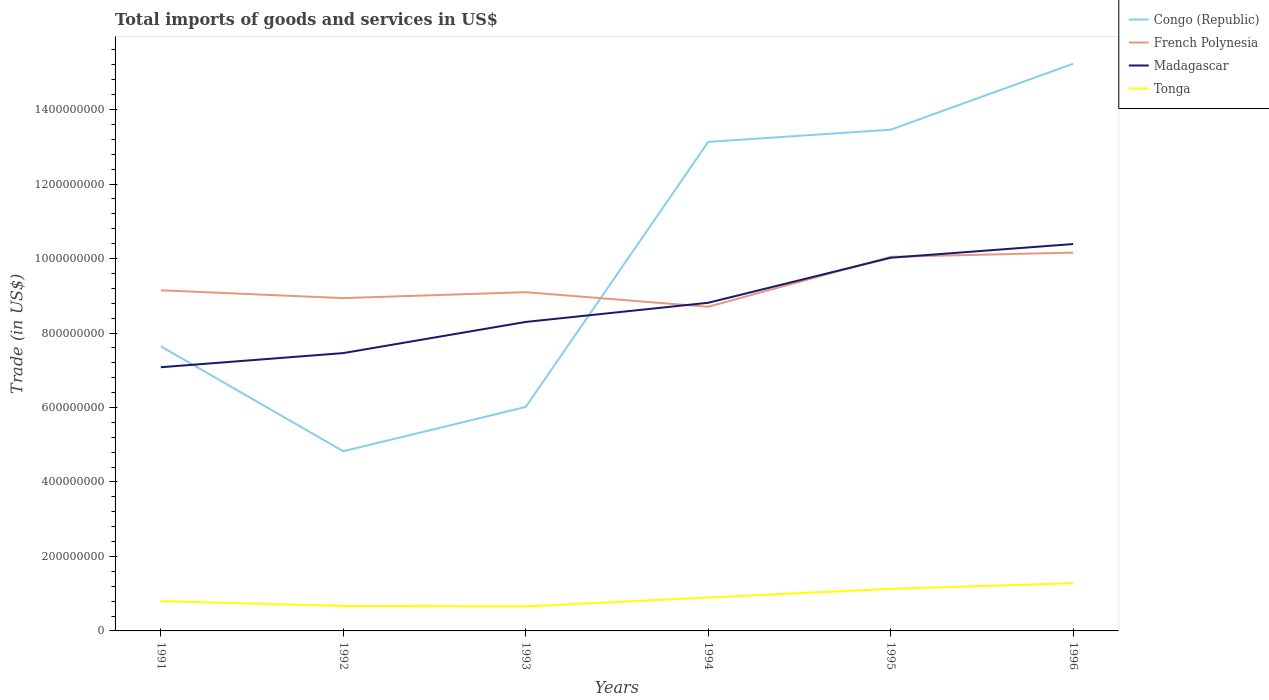Is the number of lines equal to the number of legend labels?
Your answer should be compact. Yes. Across all years, what is the maximum total imports of goods and services in Madagascar?
Make the answer very short. 7.08e+08. What is the total total imports of goods and services in Tonga in the graph?
Give a very brief answer. -4.73e+07. What is the difference between the highest and the second highest total imports of goods and services in French Polynesia?
Provide a succinct answer. 1.45e+08. How many lines are there?
Offer a very short reply. 4. Are the values on the major ticks of Y-axis written in scientific E-notation?
Provide a succinct answer. No. Does the graph contain any zero values?
Make the answer very short. No. How many legend labels are there?
Your response must be concise. 4. What is the title of the graph?
Provide a succinct answer. Total imports of goods and services in US$. Does "Burkina Faso" appear as one of the legend labels in the graph?
Ensure brevity in your answer.  No. What is the label or title of the Y-axis?
Give a very brief answer. Trade (in US$). What is the Trade (in US$) of Congo (Republic) in 1991?
Offer a terse response. 7.64e+08. What is the Trade (in US$) in French Polynesia in 1991?
Your response must be concise. 9.15e+08. What is the Trade (in US$) in Madagascar in 1991?
Give a very brief answer. 7.08e+08. What is the Trade (in US$) of Tonga in 1991?
Make the answer very short. 8.01e+07. What is the Trade (in US$) in Congo (Republic) in 1992?
Offer a terse response. 4.82e+08. What is the Trade (in US$) in French Polynesia in 1992?
Keep it short and to the point. 8.94e+08. What is the Trade (in US$) of Madagascar in 1992?
Your answer should be compact. 7.46e+08. What is the Trade (in US$) of Tonga in 1992?
Give a very brief answer. 6.71e+07. What is the Trade (in US$) in Congo (Republic) in 1993?
Keep it short and to the point. 6.01e+08. What is the Trade (in US$) of French Polynesia in 1993?
Offer a terse response. 9.10e+08. What is the Trade (in US$) of Madagascar in 1993?
Your response must be concise. 8.30e+08. What is the Trade (in US$) in Tonga in 1993?
Provide a succinct answer. 6.59e+07. What is the Trade (in US$) of Congo (Republic) in 1994?
Your answer should be very brief. 1.31e+09. What is the Trade (in US$) in French Polynesia in 1994?
Your answer should be compact. 8.70e+08. What is the Trade (in US$) in Madagascar in 1994?
Make the answer very short. 8.81e+08. What is the Trade (in US$) in Tonga in 1994?
Keep it short and to the point. 8.97e+07. What is the Trade (in US$) of Congo (Republic) in 1995?
Ensure brevity in your answer.  1.35e+09. What is the Trade (in US$) in French Polynesia in 1995?
Your answer should be compact. 1.00e+09. What is the Trade (in US$) in Madagascar in 1995?
Make the answer very short. 1.00e+09. What is the Trade (in US$) of Tonga in 1995?
Ensure brevity in your answer.  1.13e+08. What is the Trade (in US$) of Congo (Republic) in 1996?
Provide a short and direct response. 1.52e+09. What is the Trade (in US$) of French Polynesia in 1996?
Offer a very short reply. 1.02e+09. What is the Trade (in US$) of Madagascar in 1996?
Keep it short and to the point. 1.04e+09. What is the Trade (in US$) in Tonga in 1996?
Give a very brief answer. 1.28e+08. Across all years, what is the maximum Trade (in US$) of Congo (Republic)?
Ensure brevity in your answer.  1.52e+09. Across all years, what is the maximum Trade (in US$) in French Polynesia?
Ensure brevity in your answer.  1.02e+09. Across all years, what is the maximum Trade (in US$) in Madagascar?
Provide a short and direct response. 1.04e+09. Across all years, what is the maximum Trade (in US$) in Tonga?
Make the answer very short. 1.28e+08. Across all years, what is the minimum Trade (in US$) of Congo (Republic)?
Provide a succinct answer. 4.82e+08. Across all years, what is the minimum Trade (in US$) of French Polynesia?
Keep it short and to the point. 8.70e+08. Across all years, what is the minimum Trade (in US$) in Madagascar?
Provide a succinct answer. 7.08e+08. Across all years, what is the minimum Trade (in US$) in Tonga?
Make the answer very short. 6.59e+07. What is the total Trade (in US$) in Congo (Republic) in the graph?
Provide a short and direct response. 6.03e+09. What is the total Trade (in US$) of French Polynesia in the graph?
Keep it short and to the point. 5.61e+09. What is the total Trade (in US$) of Madagascar in the graph?
Offer a terse response. 5.21e+09. What is the total Trade (in US$) of Tonga in the graph?
Your answer should be compact. 5.44e+08. What is the difference between the Trade (in US$) of Congo (Republic) in 1991 and that in 1992?
Provide a succinct answer. 2.82e+08. What is the difference between the Trade (in US$) of French Polynesia in 1991 and that in 1992?
Your answer should be compact. 2.10e+07. What is the difference between the Trade (in US$) of Madagascar in 1991 and that in 1992?
Your response must be concise. -3.80e+07. What is the difference between the Trade (in US$) in Tonga in 1991 and that in 1992?
Keep it short and to the point. 1.29e+07. What is the difference between the Trade (in US$) of Congo (Republic) in 1991 and that in 1993?
Ensure brevity in your answer.  1.63e+08. What is the difference between the Trade (in US$) in French Polynesia in 1991 and that in 1993?
Keep it short and to the point. 5.07e+06. What is the difference between the Trade (in US$) of Madagascar in 1991 and that in 1993?
Your answer should be compact. -1.22e+08. What is the difference between the Trade (in US$) in Tonga in 1991 and that in 1993?
Offer a very short reply. 1.42e+07. What is the difference between the Trade (in US$) of Congo (Republic) in 1991 and that in 1994?
Provide a short and direct response. -5.49e+08. What is the difference between the Trade (in US$) of French Polynesia in 1991 and that in 1994?
Make the answer very short. 4.42e+07. What is the difference between the Trade (in US$) of Madagascar in 1991 and that in 1994?
Provide a short and direct response. -1.73e+08. What is the difference between the Trade (in US$) of Tonga in 1991 and that in 1994?
Keep it short and to the point. -9.66e+06. What is the difference between the Trade (in US$) of Congo (Republic) in 1991 and that in 1995?
Keep it short and to the point. -5.82e+08. What is the difference between the Trade (in US$) of French Polynesia in 1991 and that in 1995?
Offer a terse response. -9.00e+07. What is the difference between the Trade (in US$) of Madagascar in 1991 and that in 1995?
Offer a very short reply. -2.94e+08. What is the difference between the Trade (in US$) in Tonga in 1991 and that in 1995?
Your response must be concise. -3.31e+07. What is the difference between the Trade (in US$) of Congo (Republic) in 1991 and that in 1996?
Your answer should be very brief. -7.59e+08. What is the difference between the Trade (in US$) of French Polynesia in 1991 and that in 1996?
Provide a succinct answer. -1.01e+08. What is the difference between the Trade (in US$) of Madagascar in 1991 and that in 1996?
Give a very brief answer. -3.31e+08. What is the difference between the Trade (in US$) in Tonga in 1991 and that in 1996?
Your answer should be compact. -4.81e+07. What is the difference between the Trade (in US$) of Congo (Republic) in 1992 and that in 1993?
Give a very brief answer. -1.19e+08. What is the difference between the Trade (in US$) in French Polynesia in 1992 and that in 1993?
Give a very brief answer. -1.59e+07. What is the difference between the Trade (in US$) of Madagascar in 1992 and that in 1993?
Keep it short and to the point. -8.37e+07. What is the difference between the Trade (in US$) in Tonga in 1992 and that in 1993?
Provide a succinct answer. 1.30e+06. What is the difference between the Trade (in US$) in Congo (Republic) in 1992 and that in 1994?
Make the answer very short. -8.31e+08. What is the difference between the Trade (in US$) of French Polynesia in 1992 and that in 1994?
Your answer should be very brief. 2.32e+07. What is the difference between the Trade (in US$) in Madagascar in 1992 and that in 1994?
Offer a very short reply. -1.35e+08. What is the difference between the Trade (in US$) of Tonga in 1992 and that in 1994?
Ensure brevity in your answer.  -2.26e+07. What is the difference between the Trade (in US$) in Congo (Republic) in 1992 and that in 1995?
Your response must be concise. -8.63e+08. What is the difference between the Trade (in US$) in French Polynesia in 1992 and that in 1995?
Make the answer very short. -1.11e+08. What is the difference between the Trade (in US$) of Madagascar in 1992 and that in 1995?
Ensure brevity in your answer.  -2.56e+08. What is the difference between the Trade (in US$) in Tonga in 1992 and that in 1995?
Your response must be concise. -4.60e+07. What is the difference between the Trade (in US$) in Congo (Republic) in 1992 and that in 1996?
Provide a short and direct response. -1.04e+09. What is the difference between the Trade (in US$) in French Polynesia in 1992 and that in 1996?
Provide a short and direct response. -1.22e+08. What is the difference between the Trade (in US$) of Madagascar in 1992 and that in 1996?
Give a very brief answer. -2.93e+08. What is the difference between the Trade (in US$) in Tonga in 1992 and that in 1996?
Your response must be concise. -6.10e+07. What is the difference between the Trade (in US$) of Congo (Republic) in 1993 and that in 1994?
Keep it short and to the point. -7.12e+08. What is the difference between the Trade (in US$) of French Polynesia in 1993 and that in 1994?
Offer a very short reply. 3.92e+07. What is the difference between the Trade (in US$) in Madagascar in 1993 and that in 1994?
Provide a succinct answer. -5.14e+07. What is the difference between the Trade (in US$) of Tonga in 1993 and that in 1994?
Your answer should be very brief. -2.39e+07. What is the difference between the Trade (in US$) of Congo (Republic) in 1993 and that in 1995?
Give a very brief answer. -7.45e+08. What is the difference between the Trade (in US$) in French Polynesia in 1993 and that in 1995?
Ensure brevity in your answer.  -9.50e+07. What is the difference between the Trade (in US$) in Madagascar in 1993 and that in 1995?
Your answer should be compact. -1.72e+08. What is the difference between the Trade (in US$) of Tonga in 1993 and that in 1995?
Your answer should be very brief. -4.73e+07. What is the difference between the Trade (in US$) of Congo (Republic) in 1993 and that in 1996?
Give a very brief answer. -9.22e+08. What is the difference between the Trade (in US$) in French Polynesia in 1993 and that in 1996?
Offer a terse response. -1.06e+08. What is the difference between the Trade (in US$) of Madagascar in 1993 and that in 1996?
Your response must be concise. -2.09e+08. What is the difference between the Trade (in US$) of Tonga in 1993 and that in 1996?
Your response must be concise. -6.23e+07. What is the difference between the Trade (in US$) in Congo (Republic) in 1994 and that in 1995?
Offer a terse response. -3.27e+07. What is the difference between the Trade (in US$) in French Polynesia in 1994 and that in 1995?
Keep it short and to the point. -1.34e+08. What is the difference between the Trade (in US$) in Madagascar in 1994 and that in 1995?
Ensure brevity in your answer.  -1.21e+08. What is the difference between the Trade (in US$) of Tonga in 1994 and that in 1995?
Offer a very short reply. -2.34e+07. What is the difference between the Trade (in US$) in Congo (Republic) in 1994 and that in 1996?
Your answer should be compact. -2.10e+08. What is the difference between the Trade (in US$) in French Polynesia in 1994 and that in 1996?
Provide a short and direct response. -1.45e+08. What is the difference between the Trade (in US$) of Madagascar in 1994 and that in 1996?
Provide a succinct answer. -1.58e+08. What is the difference between the Trade (in US$) in Tonga in 1994 and that in 1996?
Your answer should be compact. -3.85e+07. What is the difference between the Trade (in US$) in Congo (Republic) in 1995 and that in 1996?
Your response must be concise. -1.77e+08. What is the difference between the Trade (in US$) in French Polynesia in 1995 and that in 1996?
Your answer should be very brief. -1.12e+07. What is the difference between the Trade (in US$) in Madagascar in 1995 and that in 1996?
Provide a succinct answer. -3.68e+07. What is the difference between the Trade (in US$) in Tonga in 1995 and that in 1996?
Your response must be concise. -1.51e+07. What is the difference between the Trade (in US$) in Congo (Republic) in 1991 and the Trade (in US$) in French Polynesia in 1992?
Your answer should be compact. -1.29e+08. What is the difference between the Trade (in US$) of Congo (Republic) in 1991 and the Trade (in US$) of Madagascar in 1992?
Offer a very short reply. 1.83e+07. What is the difference between the Trade (in US$) of Congo (Republic) in 1991 and the Trade (in US$) of Tonga in 1992?
Ensure brevity in your answer.  6.97e+08. What is the difference between the Trade (in US$) of French Polynesia in 1991 and the Trade (in US$) of Madagascar in 1992?
Give a very brief answer. 1.69e+08. What is the difference between the Trade (in US$) in French Polynesia in 1991 and the Trade (in US$) in Tonga in 1992?
Your answer should be compact. 8.48e+08. What is the difference between the Trade (in US$) in Madagascar in 1991 and the Trade (in US$) in Tonga in 1992?
Keep it short and to the point. 6.41e+08. What is the difference between the Trade (in US$) of Congo (Republic) in 1991 and the Trade (in US$) of French Polynesia in 1993?
Provide a succinct answer. -1.45e+08. What is the difference between the Trade (in US$) in Congo (Republic) in 1991 and the Trade (in US$) in Madagascar in 1993?
Ensure brevity in your answer.  -6.54e+07. What is the difference between the Trade (in US$) of Congo (Republic) in 1991 and the Trade (in US$) of Tonga in 1993?
Provide a short and direct response. 6.98e+08. What is the difference between the Trade (in US$) of French Polynesia in 1991 and the Trade (in US$) of Madagascar in 1993?
Ensure brevity in your answer.  8.49e+07. What is the difference between the Trade (in US$) of French Polynesia in 1991 and the Trade (in US$) of Tonga in 1993?
Your response must be concise. 8.49e+08. What is the difference between the Trade (in US$) of Madagascar in 1991 and the Trade (in US$) of Tonga in 1993?
Offer a very short reply. 6.42e+08. What is the difference between the Trade (in US$) of Congo (Republic) in 1991 and the Trade (in US$) of French Polynesia in 1994?
Offer a very short reply. -1.06e+08. What is the difference between the Trade (in US$) in Congo (Republic) in 1991 and the Trade (in US$) in Madagascar in 1994?
Give a very brief answer. -1.17e+08. What is the difference between the Trade (in US$) in Congo (Republic) in 1991 and the Trade (in US$) in Tonga in 1994?
Your response must be concise. 6.75e+08. What is the difference between the Trade (in US$) of French Polynesia in 1991 and the Trade (in US$) of Madagascar in 1994?
Provide a succinct answer. 3.35e+07. What is the difference between the Trade (in US$) of French Polynesia in 1991 and the Trade (in US$) of Tonga in 1994?
Give a very brief answer. 8.25e+08. What is the difference between the Trade (in US$) of Madagascar in 1991 and the Trade (in US$) of Tonga in 1994?
Your answer should be compact. 6.18e+08. What is the difference between the Trade (in US$) in Congo (Republic) in 1991 and the Trade (in US$) in French Polynesia in 1995?
Offer a very short reply. -2.40e+08. What is the difference between the Trade (in US$) of Congo (Republic) in 1991 and the Trade (in US$) of Madagascar in 1995?
Keep it short and to the point. -2.38e+08. What is the difference between the Trade (in US$) of Congo (Republic) in 1991 and the Trade (in US$) of Tonga in 1995?
Provide a short and direct response. 6.51e+08. What is the difference between the Trade (in US$) of French Polynesia in 1991 and the Trade (in US$) of Madagascar in 1995?
Provide a succinct answer. -8.74e+07. What is the difference between the Trade (in US$) in French Polynesia in 1991 and the Trade (in US$) in Tonga in 1995?
Make the answer very short. 8.02e+08. What is the difference between the Trade (in US$) of Madagascar in 1991 and the Trade (in US$) of Tonga in 1995?
Ensure brevity in your answer.  5.95e+08. What is the difference between the Trade (in US$) of Congo (Republic) in 1991 and the Trade (in US$) of French Polynesia in 1996?
Offer a terse response. -2.52e+08. What is the difference between the Trade (in US$) in Congo (Republic) in 1991 and the Trade (in US$) in Madagascar in 1996?
Provide a succinct answer. -2.75e+08. What is the difference between the Trade (in US$) of Congo (Republic) in 1991 and the Trade (in US$) of Tonga in 1996?
Your answer should be very brief. 6.36e+08. What is the difference between the Trade (in US$) in French Polynesia in 1991 and the Trade (in US$) in Madagascar in 1996?
Offer a terse response. -1.24e+08. What is the difference between the Trade (in US$) in French Polynesia in 1991 and the Trade (in US$) in Tonga in 1996?
Give a very brief answer. 7.86e+08. What is the difference between the Trade (in US$) of Madagascar in 1991 and the Trade (in US$) of Tonga in 1996?
Offer a very short reply. 5.80e+08. What is the difference between the Trade (in US$) of Congo (Republic) in 1992 and the Trade (in US$) of French Polynesia in 1993?
Provide a succinct answer. -4.27e+08. What is the difference between the Trade (in US$) in Congo (Republic) in 1992 and the Trade (in US$) in Madagascar in 1993?
Make the answer very short. -3.47e+08. What is the difference between the Trade (in US$) in Congo (Republic) in 1992 and the Trade (in US$) in Tonga in 1993?
Offer a terse response. 4.17e+08. What is the difference between the Trade (in US$) of French Polynesia in 1992 and the Trade (in US$) of Madagascar in 1993?
Give a very brief answer. 6.39e+07. What is the difference between the Trade (in US$) in French Polynesia in 1992 and the Trade (in US$) in Tonga in 1993?
Make the answer very short. 8.28e+08. What is the difference between the Trade (in US$) in Madagascar in 1992 and the Trade (in US$) in Tonga in 1993?
Ensure brevity in your answer.  6.80e+08. What is the difference between the Trade (in US$) in Congo (Republic) in 1992 and the Trade (in US$) in French Polynesia in 1994?
Provide a short and direct response. -3.88e+08. What is the difference between the Trade (in US$) of Congo (Republic) in 1992 and the Trade (in US$) of Madagascar in 1994?
Keep it short and to the point. -3.99e+08. What is the difference between the Trade (in US$) in Congo (Republic) in 1992 and the Trade (in US$) in Tonga in 1994?
Ensure brevity in your answer.  3.93e+08. What is the difference between the Trade (in US$) in French Polynesia in 1992 and the Trade (in US$) in Madagascar in 1994?
Keep it short and to the point. 1.25e+07. What is the difference between the Trade (in US$) of French Polynesia in 1992 and the Trade (in US$) of Tonga in 1994?
Your answer should be very brief. 8.04e+08. What is the difference between the Trade (in US$) in Madagascar in 1992 and the Trade (in US$) in Tonga in 1994?
Your answer should be compact. 6.56e+08. What is the difference between the Trade (in US$) in Congo (Republic) in 1992 and the Trade (in US$) in French Polynesia in 1995?
Your answer should be compact. -5.22e+08. What is the difference between the Trade (in US$) of Congo (Republic) in 1992 and the Trade (in US$) of Madagascar in 1995?
Give a very brief answer. -5.20e+08. What is the difference between the Trade (in US$) in Congo (Republic) in 1992 and the Trade (in US$) in Tonga in 1995?
Your answer should be compact. 3.69e+08. What is the difference between the Trade (in US$) in French Polynesia in 1992 and the Trade (in US$) in Madagascar in 1995?
Keep it short and to the point. -1.08e+08. What is the difference between the Trade (in US$) of French Polynesia in 1992 and the Trade (in US$) of Tonga in 1995?
Make the answer very short. 7.81e+08. What is the difference between the Trade (in US$) of Madagascar in 1992 and the Trade (in US$) of Tonga in 1995?
Give a very brief answer. 6.33e+08. What is the difference between the Trade (in US$) of Congo (Republic) in 1992 and the Trade (in US$) of French Polynesia in 1996?
Provide a succinct answer. -5.33e+08. What is the difference between the Trade (in US$) in Congo (Republic) in 1992 and the Trade (in US$) in Madagascar in 1996?
Offer a terse response. -5.56e+08. What is the difference between the Trade (in US$) of Congo (Republic) in 1992 and the Trade (in US$) of Tonga in 1996?
Your answer should be compact. 3.54e+08. What is the difference between the Trade (in US$) of French Polynesia in 1992 and the Trade (in US$) of Madagascar in 1996?
Your answer should be very brief. -1.45e+08. What is the difference between the Trade (in US$) of French Polynesia in 1992 and the Trade (in US$) of Tonga in 1996?
Your answer should be compact. 7.65e+08. What is the difference between the Trade (in US$) of Madagascar in 1992 and the Trade (in US$) of Tonga in 1996?
Your response must be concise. 6.18e+08. What is the difference between the Trade (in US$) in Congo (Republic) in 1993 and the Trade (in US$) in French Polynesia in 1994?
Ensure brevity in your answer.  -2.69e+08. What is the difference between the Trade (in US$) of Congo (Republic) in 1993 and the Trade (in US$) of Madagascar in 1994?
Make the answer very short. -2.80e+08. What is the difference between the Trade (in US$) of Congo (Republic) in 1993 and the Trade (in US$) of Tonga in 1994?
Your answer should be very brief. 5.12e+08. What is the difference between the Trade (in US$) in French Polynesia in 1993 and the Trade (in US$) in Madagascar in 1994?
Keep it short and to the point. 2.84e+07. What is the difference between the Trade (in US$) of French Polynesia in 1993 and the Trade (in US$) of Tonga in 1994?
Your answer should be very brief. 8.20e+08. What is the difference between the Trade (in US$) of Madagascar in 1993 and the Trade (in US$) of Tonga in 1994?
Your answer should be very brief. 7.40e+08. What is the difference between the Trade (in US$) of Congo (Republic) in 1993 and the Trade (in US$) of French Polynesia in 1995?
Keep it short and to the point. -4.03e+08. What is the difference between the Trade (in US$) of Congo (Republic) in 1993 and the Trade (in US$) of Madagascar in 1995?
Make the answer very short. -4.01e+08. What is the difference between the Trade (in US$) of Congo (Republic) in 1993 and the Trade (in US$) of Tonga in 1995?
Make the answer very short. 4.88e+08. What is the difference between the Trade (in US$) in French Polynesia in 1993 and the Trade (in US$) in Madagascar in 1995?
Provide a short and direct response. -9.25e+07. What is the difference between the Trade (in US$) of French Polynesia in 1993 and the Trade (in US$) of Tonga in 1995?
Offer a terse response. 7.96e+08. What is the difference between the Trade (in US$) in Madagascar in 1993 and the Trade (in US$) in Tonga in 1995?
Your answer should be compact. 7.17e+08. What is the difference between the Trade (in US$) in Congo (Republic) in 1993 and the Trade (in US$) in French Polynesia in 1996?
Your response must be concise. -4.14e+08. What is the difference between the Trade (in US$) of Congo (Republic) in 1993 and the Trade (in US$) of Madagascar in 1996?
Ensure brevity in your answer.  -4.37e+08. What is the difference between the Trade (in US$) of Congo (Republic) in 1993 and the Trade (in US$) of Tonga in 1996?
Offer a terse response. 4.73e+08. What is the difference between the Trade (in US$) of French Polynesia in 1993 and the Trade (in US$) of Madagascar in 1996?
Ensure brevity in your answer.  -1.29e+08. What is the difference between the Trade (in US$) of French Polynesia in 1993 and the Trade (in US$) of Tonga in 1996?
Ensure brevity in your answer.  7.81e+08. What is the difference between the Trade (in US$) in Madagascar in 1993 and the Trade (in US$) in Tonga in 1996?
Make the answer very short. 7.02e+08. What is the difference between the Trade (in US$) of Congo (Republic) in 1994 and the Trade (in US$) of French Polynesia in 1995?
Your answer should be very brief. 3.09e+08. What is the difference between the Trade (in US$) of Congo (Republic) in 1994 and the Trade (in US$) of Madagascar in 1995?
Provide a short and direct response. 3.11e+08. What is the difference between the Trade (in US$) in Congo (Republic) in 1994 and the Trade (in US$) in Tonga in 1995?
Give a very brief answer. 1.20e+09. What is the difference between the Trade (in US$) in French Polynesia in 1994 and the Trade (in US$) in Madagascar in 1995?
Offer a very short reply. -1.32e+08. What is the difference between the Trade (in US$) in French Polynesia in 1994 and the Trade (in US$) in Tonga in 1995?
Your answer should be very brief. 7.57e+08. What is the difference between the Trade (in US$) in Madagascar in 1994 and the Trade (in US$) in Tonga in 1995?
Give a very brief answer. 7.68e+08. What is the difference between the Trade (in US$) of Congo (Republic) in 1994 and the Trade (in US$) of French Polynesia in 1996?
Your answer should be compact. 2.97e+08. What is the difference between the Trade (in US$) in Congo (Republic) in 1994 and the Trade (in US$) in Madagascar in 1996?
Give a very brief answer. 2.74e+08. What is the difference between the Trade (in US$) of Congo (Republic) in 1994 and the Trade (in US$) of Tonga in 1996?
Offer a terse response. 1.19e+09. What is the difference between the Trade (in US$) of French Polynesia in 1994 and the Trade (in US$) of Madagascar in 1996?
Your response must be concise. -1.68e+08. What is the difference between the Trade (in US$) in French Polynesia in 1994 and the Trade (in US$) in Tonga in 1996?
Give a very brief answer. 7.42e+08. What is the difference between the Trade (in US$) of Madagascar in 1994 and the Trade (in US$) of Tonga in 1996?
Offer a terse response. 7.53e+08. What is the difference between the Trade (in US$) in Congo (Republic) in 1995 and the Trade (in US$) in French Polynesia in 1996?
Provide a succinct answer. 3.30e+08. What is the difference between the Trade (in US$) of Congo (Republic) in 1995 and the Trade (in US$) of Madagascar in 1996?
Your answer should be very brief. 3.07e+08. What is the difference between the Trade (in US$) in Congo (Republic) in 1995 and the Trade (in US$) in Tonga in 1996?
Ensure brevity in your answer.  1.22e+09. What is the difference between the Trade (in US$) in French Polynesia in 1995 and the Trade (in US$) in Madagascar in 1996?
Offer a terse response. -3.43e+07. What is the difference between the Trade (in US$) in French Polynesia in 1995 and the Trade (in US$) in Tonga in 1996?
Give a very brief answer. 8.76e+08. What is the difference between the Trade (in US$) of Madagascar in 1995 and the Trade (in US$) of Tonga in 1996?
Provide a succinct answer. 8.74e+08. What is the average Trade (in US$) of Congo (Republic) per year?
Ensure brevity in your answer.  1.01e+09. What is the average Trade (in US$) in French Polynesia per year?
Your answer should be very brief. 9.35e+08. What is the average Trade (in US$) of Madagascar per year?
Your answer should be very brief. 8.68e+08. What is the average Trade (in US$) of Tonga per year?
Offer a terse response. 9.07e+07. In the year 1991, what is the difference between the Trade (in US$) in Congo (Republic) and Trade (in US$) in French Polynesia?
Make the answer very short. -1.50e+08. In the year 1991, what is the difference between the Trade (in US$) of Congo (Republic) and Trade (in US$) of Madagascar?
Give a very brief answer. 5.62e+07. In the year 1991, what is the difference between the Trade (in US$) of Congo (Republic) and Trade (in US$) of Tonga?
Provide a succinct answer. 6.84e+08. In the year 1991, what is the difference between the Trade (in US$) of French Polynesia and Trade (in US$) of Madagascar?
Offer a terse response. 2.07e+08. In the year 1991, what is the difference between the Trade (in US$) of French Polynesia and Trade (in US$) of Tonga?
Your answer should be very brief. 8.35e+08. In the year 1991, what is the difference between the Trade (in US$) in Madagascar and Trade (in US$) in Tonga?
Your response must be concise. 6.28e+08. In the year 1992, what is the difference between the Trade (in US$) of Congo (Republic) and Trade (in US$) of French Polynesia?
Your response must be concise. -4.11e+08. In the year 1992, what is the difference between the Trade (in US$) in Congo (Republic) and Trade (in US$) in Madagascar?
Provide a succinct answer. -2.64e+08. In the year 1992, what is the difference between the Trade (in US$) of Congo (Republic) and Trade (in US$) of Tonga?
Give a very brief answer. 4.15e+08. In the year 1992, what is the difference between the Trade (in US$) in French Polynesia and Trade (in US$) in Madagascar?
Ensure brevity in your answer.  1.48e+08. In the year 1992, what is the difference between the Trade (in US$) in French Polynesia and Trade (in US$) in Tonga?
Offer a very short reply. 8.27e+08. In the year 1992, what is the difference between the Trade (in US$) of Madagascar and Trade (in US$) of Tonga?
Ensure brevity in your answer.  6.79e+08. In the year 1993, what is the difference between the Trade (in US$) of Congo (Republic) and Trade (in US$) of French Polynesia?
Your response must be concise. -3.08e+08. In the year 1993, what is the difference between the Trade (in US$) in Congo (Republic) and Trade (in US$) in Madagascar?
Your answer should be very brief. -2.28e+08. In the year 1993, what is the difference between the Trade (in US$) in Congo (Republic) and Trade (in US$) in Tonga?
Keep it short and to the point. 5.36e+08. In the year 1993, what is the difference between the Trade (in US$) of French Polynesia and Trade (in US$) of Madagascar?
Offer a terse response. 7.98e+07. In the year 1993, what is the difference between the Trade (in US$) of French Polynesia and Trade (in US$) of Tonga?
Ensure brevity in your answer.  8.44e+08. In the year 1993, what is the difference between the Trade (in US$) of Madagascar and Trade (in US$) of Tonga?
Make the answer very short. 7.64e+08. In the year 1994, what is the difference between the Trade (in US$) in Congo (Republic) and Trade (in US$) in French Polynesia?
Keep it short and to the point. 4.43e+08. In the year 1994, what is the difference between the Trade (in US$) of Congo (Republic) and Trade (in US$) of Madagascar?
Make the answer very short. 4.32e+08. In the year 1994, what is the difference between the Trade (in US$) in Congo (Republic) and Trade (in US$) in Tonga?
Provide a succinct answer. 1.22e+09. In the year 1994, what is the difference between the Trade (in US$) of French Polynesia and Trade (in US$) of Madagascar?
Provide a succinct answer. -1.07e+07. In the year 1994, what is the difference between the Trade (in US$) in French Polynesia and Trade (in US$) in Tonga?
Your answer should be very brief. 7.81e+08. In the year 1994, what is the difference between the Trade (in US$) of Madagascar and Trade (in US$) of Tonga?
Your answer should be compact. 7.91e+08. In the year 1995, what is the difference between the Trade (in US$) in Congo (Republic) and Trade (in US$) in French Polynesia?
Your answer should be compact. 3.41e+08. In the year 1995, what is the difference between the Trade (in US$) in Congo (Republic) and Trade (in US$) in Madagascar?
Give a very brief answer. 3.44e+08. In the year 1995, what is the difference between the Trade (in US$) in Congo (Republic) and Trade (in US$) in Tonga?
Give a very brief answer. 1.23e+09. In the year 1995, what is the difference between the Trade (in US$) of French Polynesia and Trade (in US$) of Madagascar?
Provide a short and direct response. 2.58e+06. In the year 1995, what is the difference between the Trade (in US$) in French Polynesia and Trade (in US$) in Tonga?
Offer a terse response. 8.92e+08. In the year 1995, what is the difference between the Trade (in US$) in Madagascar and Trade (in US$) in Tonga?
Offer a very short reply. 8.89e+08. In the year 1996, what is the difference between the Trade (in US$) in Congo (Republic) and Trade (in US$) in French Polynesia?
Provide a short and direct response. 5.07e+08. In the year 1996, what is the difference between the Trade (in US$) in Congo (Republic) and Trade (in US$) in Madagascar?
Offer a terse response. 4.84e+08. In the year 1996, what is the difference between the Trade (in US$) in Congo (Republic) and Trade (in US$) in Tonga?
Your answer should be very brief. 1.39e+09. In the year 1996, what is the difference between the Trade (in US$) in French Polynesia and Trade (in US$) in Madagascar?
Your response must be concise. -2.31e+07. In the year 1996, what is the difference between the Trade (in US$) of French Polynesia and Trade (in US$) of Tonga?
Provide a succinct answer. 8.88e+08. In the year 1996, what is the difference between the Trade (in US$) of Madagascar and Trade (in US$) of Tonga?
Offer a very short reply. 9.11e+08. What is the ratio of the Trade (in US$) in Congo (Republic) in 1991 to that in 1992?
Your answer should be compact. 1.58. What is the ratio of the Trade (in US$) in French Polynesia in 1991 to that in 1992?
Make the answer very short. 1.02. What is the ratio of the Trade (in US$) in Madagascar in 1991 to that in 1992?
Keep it short and to the point. 0.95. What is the ratio of the Trade (in US$) in Tonga in 1991 to that in 1992?
Ensure brevity in your answer.  1.19. What is the ratio of the Trade (in US$) of Congo (Republic) in 1991 to that in 1993?
Give a very brief answer. 1.27. What is the ratio of the Trade (in US$) of French Polynesia in 1991 to that in 1993?
Your answer should be compact. 1.01. What is the ratio of the Trade (in US$) in Madagascar in 1991 to that in 1993?
Your answer should be very brief. 0.85. What is the ratio of the Trade (in US$) of Tonga in 1991 to that in 1993?
Your response must be concise. 1.22. What is the ratio of the Trade (in US$) in Congo (Republic) in 1991 to that in 1994?
Offer a very short reply. 0.58. What is the ratio of the Trade (in US$) in French Polynesia in 1991 to that in 1994?
Give a very brief answer. 1.05. What is the ratio of the Trade (in US$) in Madagascar in 1991 to that in 1994?
Your answer should be very brief. 0.8. What is the ratio of the Trade (in US$) in Tonga in 1991 to that in 1994?
Provide a succinct answer. 0.89. What is the ratio of the Trade (in US$) in Congo (Republic) in 1991 to that in 1995?
Provide a short and direct response. 0.57. What is the ratio of the Trade (in US$) of French Polynesia in 1991 to that in 1995?
Give a very brief answer. 0.91. What is the ratio of the Trade (in US$) of Madagascar in 1991 to that in 1995?
Offer a terse response. 0.71. What is the ratio of the Trade (in US$) in Tonga in 1991 to that in 1995?
Offer a terse response. 0.71. What is the ratio of the Trade (in US$) of Congo (Republic) in 1991 to that in 1996?
Provide a succinct answer. 0.5. What is the ratio of the Trade (in US$) in French Polynesia in 1991 to that in 1996?
Offer a very short reply. 0.9. What is the ratio of the Trade (in US$) of Madagascar in 1991 to that in 1996?
Provide a succinct answer. 0.68. What is the ratio of the Trade (in US$) of Tonga in 1991 to that in 1996?
Offer a terse response. 0.62. What is the ratio of the Trade (in US$) in Congo (Republic) in 1992 to that in 1993?
Offer a terse response. 0.8. What is the ratio of the Trade (in US$) in French Polynesia in 1992 to that in 1993?
Offer a terse response. 0.98. What is the ratio of the Trade (in US$) of Madagascar in 1992 to that in 1993?
Your answer should be very brief. 0.9. What is the ratio of the Trade (in US$) in Tonga in 1992 to that in 1993?
Make the answer very short. 1.02. What is the ratio of the Trade (in US$) of Congo (Republic) in 1992 to that in 1994?
Your answer should be compact. 0.37. What is the ratio of the Trade (in US$) of French Polynesia in 1992 to that in 1994?
Provide a short and direct response. 1.03. What is the ratio of the Trade (in US$) of Madagascar in 1992 to that in 1994?
Offer a very short reply. 0.85. What is the ratio of the Trade (in US$) of Tonga in 1992 to that in 1994?
Your response must be concise. 0.75. What is the ratio of the Trade (in US$) of Congo (Republic) in 1992 to that in 1995?
Your response must be concise. 0.36. What is the ratio of the Trade (in US$) in French Polynesia in 1992 to that in 1995?
Provide a short and direct response. 0.89. What is the ratio of the Trade (in US$) in Madagascar in 1992 to that in 1995?
Your answer should be compact. 0.74. What is the ratio of the Trade (in US$) in Tonga in 1992 to that in 1995?
Your response must be concise. 0.59. What is the ratio of the Trade (in US$) in Congo (Republic) in 1992 to that in 1996?
Your answer should be very brief. 0.32. What is the ratio of the Trade (in US$) of French Polynesia in 1992 to that in 1996?
Your answer should be compact. 0.88. What is the ratio of the Trade (in US$) of Madagascar in 1992 to that in 1996?
Offer a terse response. 0.72. What is the ratio of the Trade (in US$) in Tonga in 1992 to that in 1996?
Keep it short and to the point. 0.52. What is the ratio of the Trade (in US$) in Congo (Republic) in 1993 to that in 1994?
Give a very brief answer. 0.46. What is the ratio of the Trade (in US$) in French Polynesia in 1993 to that in 1994?
Your response must be concise. 1.04. What is the ratio of the Trade (in US$) in Madagascar in 1993 to that in 1994?
Keep it short and to the point. 0.94. What is the ratio of the Trade (in US$) in Tonga in 1993 to that in 1994?
Give a very brief answer. 0.73. What is the ratio of the Trade (in US$) of Congo (Republic) in 1993 to that in 1995?
Ensure brevity in your answer.  0.45. What is the ratio of the Trade (in US$) in French Polynesia in 1993 to that in 1995?
Offer a very short reply. 0.91. What is the ratio of the Trade (in US$) in Madagascar in 1993 to that in 1995?
Your response must be concise. 0.83. What is the ratio of the Trade (in US$) of Tonga in 1993 to that in 1995?
Ensure brevity in your answer.  0.58. What is the ratio of the Trade (in US$) in Congo (Republic) in 1993 to that in 1996?
Your answer should be very brief. 0.39. What is the ratio of the Trade (in US$) of French Polynesia in 1993 to that in 1996?
Provide a short and direct response. 0.9. What is the ratio of the Trade (in US$) in Madagascar in 1993 to that in 1996?
Offer a terse response. 0.8. What is the ratio of the Trade (in US$) in Tonga in 1993 to that in 1996?
Make the answer very short. 0.51. What is the ratio of the Trade (in US$) of Congo (Republic) in 1994 to that in 1995?
Provide a succinct answer. 0.98. What is the ratio of the Trade (in US$) of French Polynesia in 1994 to that in 1995?
Keep it short and to the point. 0.87. What is the ratio of the Trade (in US$) of Madagascar in 1994 to that in 1995?
Offer a terse response. 0.88. What is the ratio of the Trade (in US$) of Tonga in 1994 to that in 1995?
Provide a short and direct response. 0.79. What is the ratio of the Trade (in US$) in Congo (Republic) in 1994 to that in 1996?
Offer a very short reply. 0.86. What is the ratio of the Trade (in US$) of French Polynesia in 1994 to that in 1996?
Make the answer very short. 0.86. What is the ratio of the Trade (in US$) of Madagascar in 1994 to that in 1996?
Provide a short and direct response. 0.85. What is the ratio of the Trade (in US$) in Tonga in 1994 to that in 1996?
Provide a short and direct response. 0.7. What is the ratio of the Trade (in US$) in Congo (Republic) in 1995 to that in 1996?
Your response must be concise. 0.88. What is the ratio of the Trade (in US$) of Madagascar in 1995 to that in 1996?
Provide a short and direct response. 0.96. What is the ratio of the Trade (in US$) in Tonga in 1995 to that in 1996?
Offer a very short reply. 0.88. What is the difference between the highest and the second highest Trade (in US$) in Congo (Republic)?
Make the answer very short. 1.77e+08. What is the difference between the highest and the second highest Trade (in US$) of French Polynesia?
Offer a terse response. 1.12e+07. What is the difference between the highest and the second highest Trade (in US$) in Madagascar?
Provide a short and direct response. 3.68e+07. What is the difference between the highest and the second highest Trade (in US$) in Tonga?
Your response must be concise. 1.51e+07. What is the difference between the highest and the lowest Trade (in US$) of Congo (Republic)?
Offer a very short reply. 1.04e+09. What is the difference between the highest and the lowest Trade (in US$) in French Polynesia?
Give a very brief answer. 1.45e+08. What is the difference between the highest and the lowest Trade (in US$) in Madagascar?
Offer a very short reply. 3.31e+08. What is the difference between the highest and the lowest Trade (in US$) in Tonga?
Give a very brief answer. 6.23e+07. 